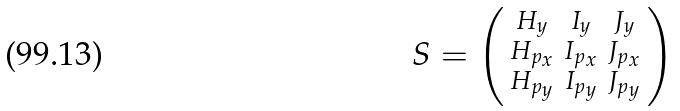Convert formula to latex. <formula><loc_0><loc_0><loc_500><loc_500>S = \begin{psmallmatrix} H _ { y } & I _ { y } & J _ { y } \\ H _ { p _ { x } } & I _ { p _ { x } } & J _ { p _ { x } } \\ H _ { p _ { y } } & I _ { p _ { y } } & J _ { p _ { y } } \end{psmallmatrix}</formula> 